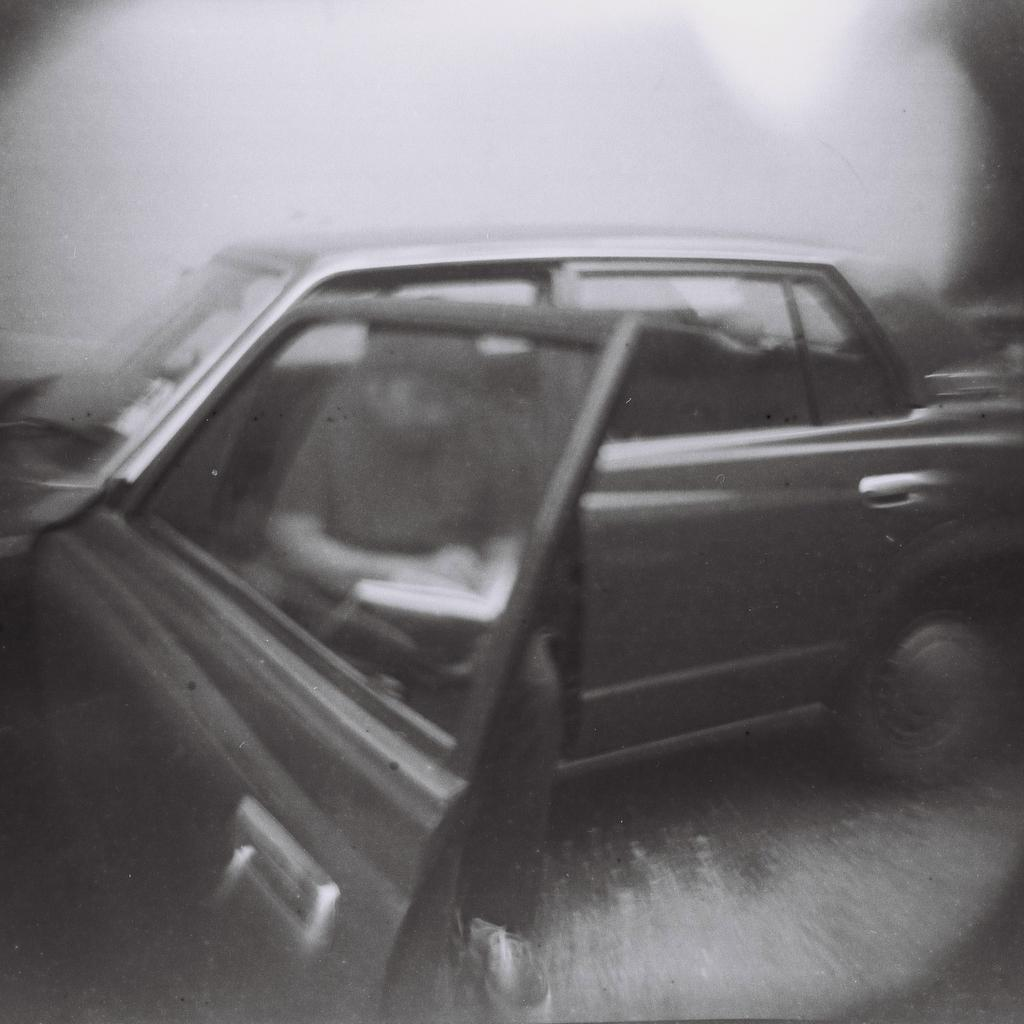What is the main subject in the center of the image? There is a car in the center of the image. Is there anyone inside the car? Yes, there is a person sitting in the car. What is the person holding in his hand? The person is holding a book in his hand. What type of canvas is being used to teach the person in the car? There is no canvas or teaching activity present in the image. 